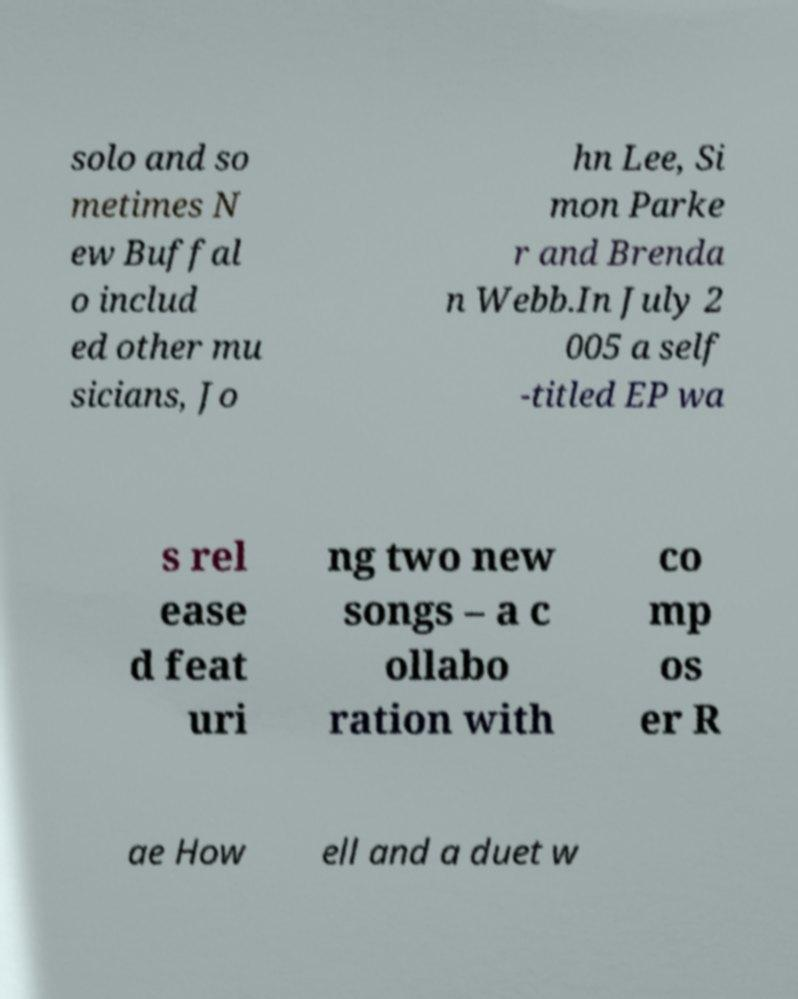What messages or text are displayed in this image? I need them in a readable, typed format. solo and so metimes N ew Buffal o includ ed other mu sicians, Jo hn Lee, Si mon Parke r and Brenda n Webb.In July 2 005 a self -titled EP wa s rel ease d feat uri ng two new songs – a c ollabo ration with co mp os er R ae How ell and a duet w 